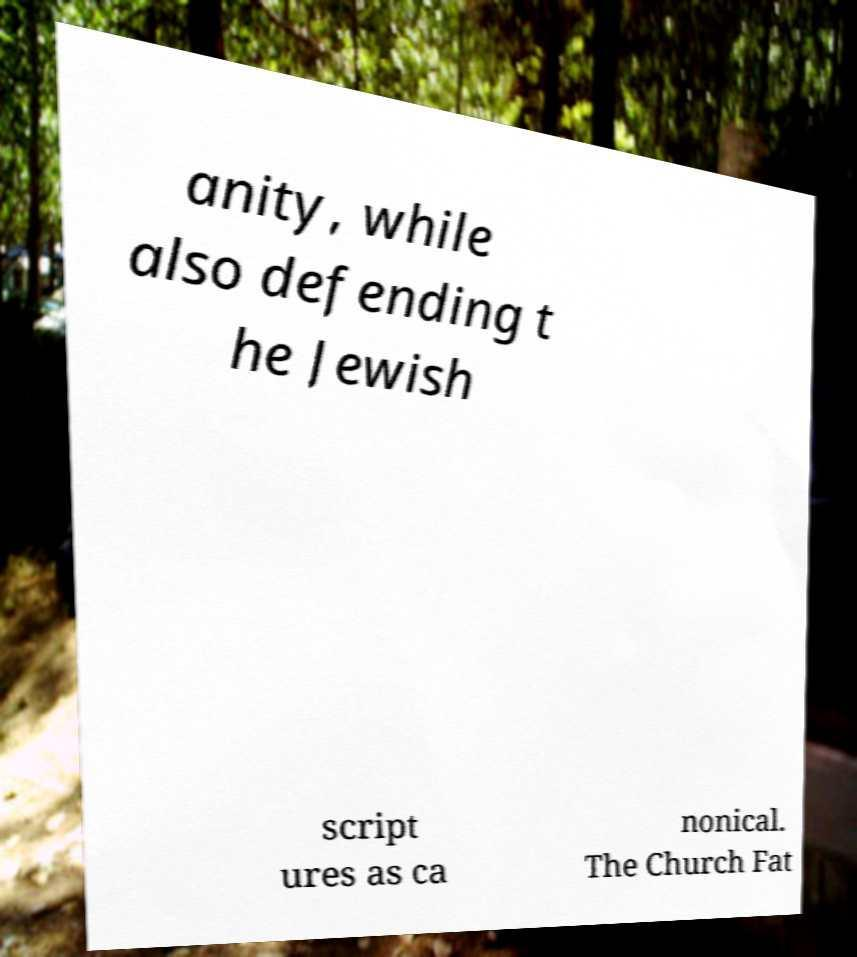Could you assist in decoding the text presented in this image and type it out clearly? anity, while also defending t he Jewish script ures as ca nonical. The Church Fat 